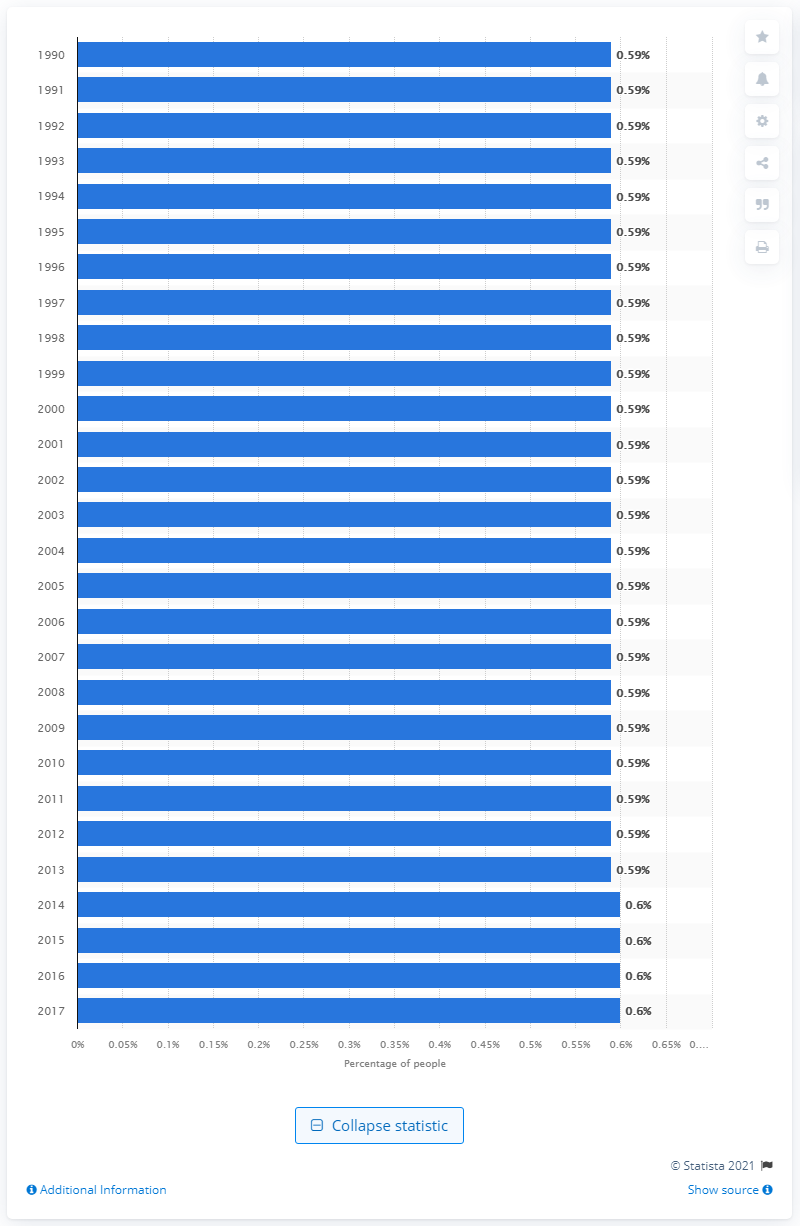Identify some key points in this picture. Approximately 0.6% of the world's population is affected by bipolar disorder each year. 